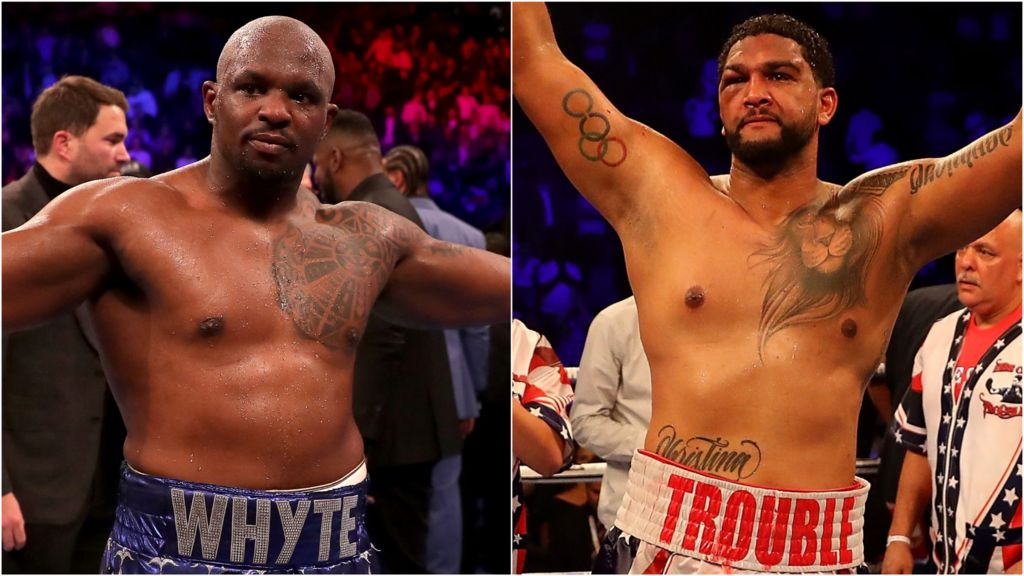How do the boxers' expressions and body language reflect their mindset before or after a match? The boxers' expressions and body language in the image can offer insight into their mindset either before or after a match. Both individuals display a blend of intensity and focus, which are vital traits for a competitor in the high-stakes world of boxing. The boxer on the left, with his raised arms and composed expression, could be basking in the aftermath of a victory, reflecting confidence and self-assuredness. His posture might signify triumphant relief and the validation of his hard work and strategy paying off. The boxer on the right, with a more solemn yet unyielding expression, may be reflecting on the physical and mental demands of the match, illustrating resilience and a determined spirit whether in victory or in contemplation of improvement for future matches. 